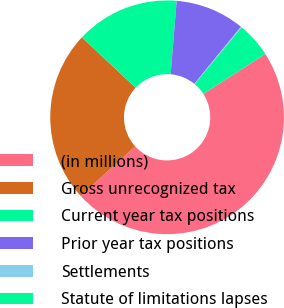Convert chart. <chart><loc_0><loc_0><loc_500><loc_500><pie_chart><fcel>(in millions)<fcel>Gross unrecognized tax<fcel>Current year tax positions<fcel>Prior year tax positions<fcel>Settlements<fcel>Statute of limitations lapses<nl><fcel>47.36%<fcel>23.75%<fcel>14.31%<fcel>9.58%<fcel>0.14%<fcel>4.86%<nl></chart> 